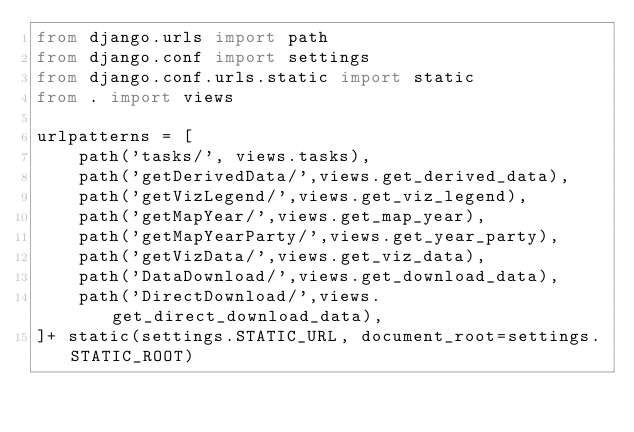<code> <loc_0><loc_0><loc_500><loc_500><_Python_>from django.urls import path
from django.conf import settings
from django.conf.urls.static import static
from . import views

urlpatterns = [
    path('tasks/', views.tasks),
    path('getDerivedData/',views.get_derived_data),
    path('getVizLegend/',views.get_viz_legend),
    path('getMapYear/',views.get_map_year),
    path('getMapYearParty/',views.get_year_party),
    path('getVizData/',views.get_viz_data),
    path('DataDownload/',views.get_download_data),
    path('DirectDownload/',views.get_direct_download_data),
]+ static(settings.STATIC_URL, document_root=settings.STATIC_ROOT)
</code> 